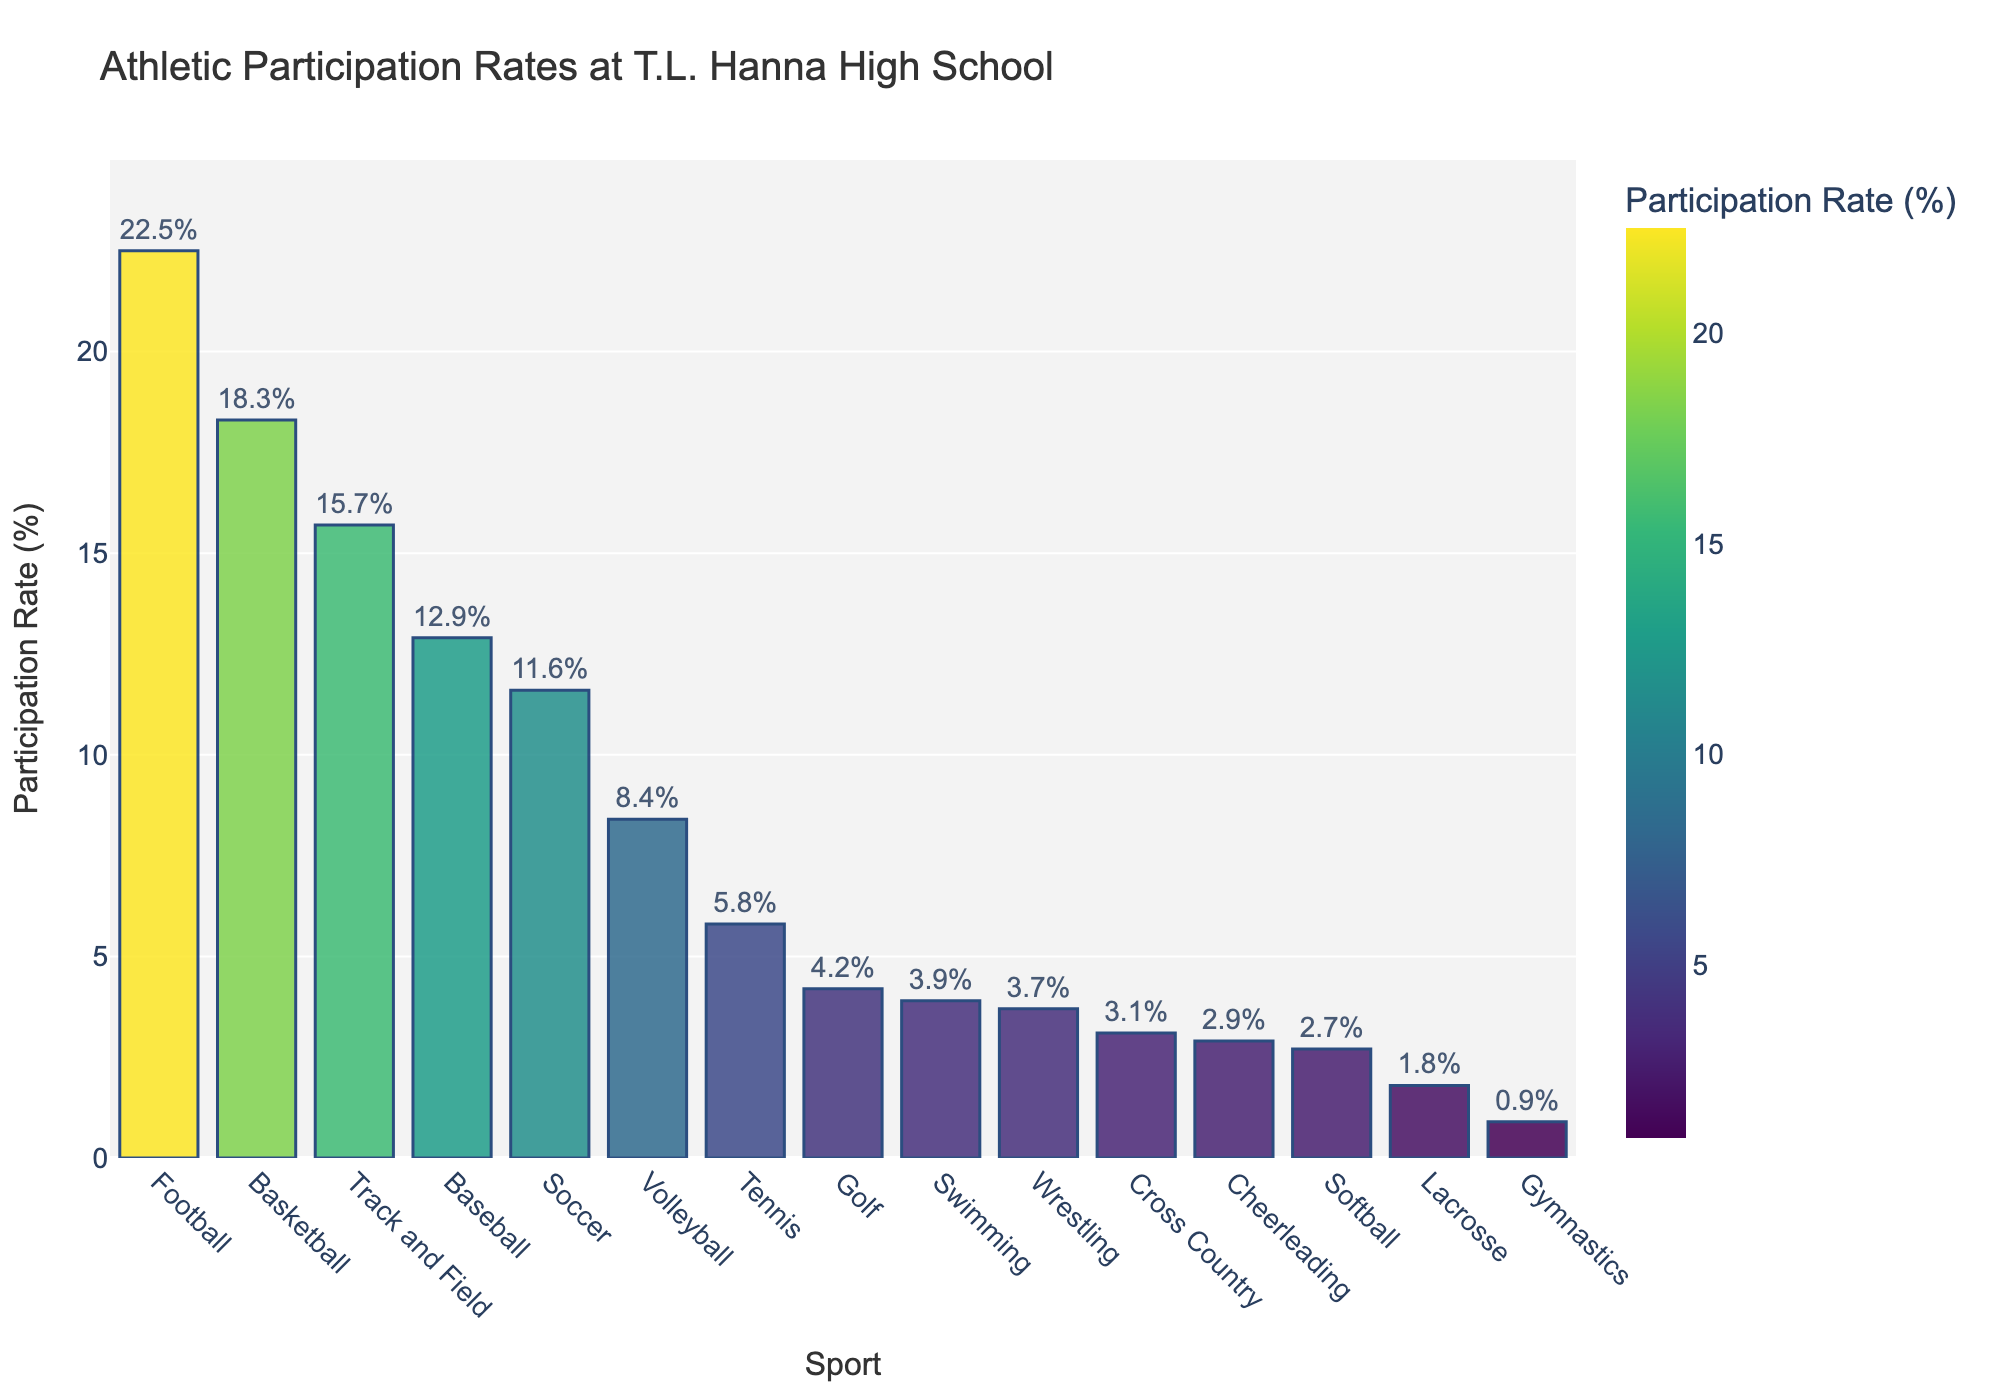What sport has the highest participation rate? Look for the sport with the tallest bar in the chart, representing the highest participation rate percentage.
Answer: Football Which two sports have participation rates between 10% and 20%? Identify the bars in the chart whose height falls within the 10% to 20% range. These represent sports with participation rates in this range.
Answer: Basketball and Track and Field Which sport has the lowest participation rate? Find the bar with the smallest height in the chart, indicating the lowest participation rate percentage.
Answer: Gymnastics What is the combined participation rate for Soccer, Volleyball, and Tennis? Add the participation rates of Soccer (11.6%), Volleyball (8.4%), and Tennis (5.8%). The sum is the combined participation rate. 11.6 + 8.4 + 5.8 = 25.8
Answer: 25.8 Is the participation rate for Baseball greater than that for Soccer? Compare the heights of the bars for Baseball (12.9%) and Soccer (11.6%). Determine if the Baseball bar is taller.
Answer: Yes Which sports have a participation rate of over 15%? Identify sports with bars that extend above the 15% mark on the y-axis, indicating a participation rate greater than 15%.
Answer: Football, Basketball, and Track and Field What is the difference in participation rates between Swimming and Wrestling? Calculate the difference between the participation rates of Swimming (3.9%) and Wrestling (3.7%). Subtract the lower value from the higher value: 3.9 - 3.7 = 0.2
Answer: 0.2 Which bar is colored in the darkest hue? What sport does it represent? The darkest hue represents the highest participation rate. Identify the sport associated with the darkest colored bar.
Answer: Football How many sports have a participation rate below 5%? Count the number of bars in the chart whose height is below the 5% mark on the y-axis.
Answer: Six What is the average participation rate for all the sports? Sum all the participation rates, then divide by the number of sports (15). (22.5 + 18.3 + 15.7 + 12.9 + 11.6 + 8.4 + 5.8 + 4.2 + 3.9 + 3.7 + 3.1 + 2.9 + 2.7 + 1.8 + 0.9) / 15 ≈ 8.0
Answer: 8.0 